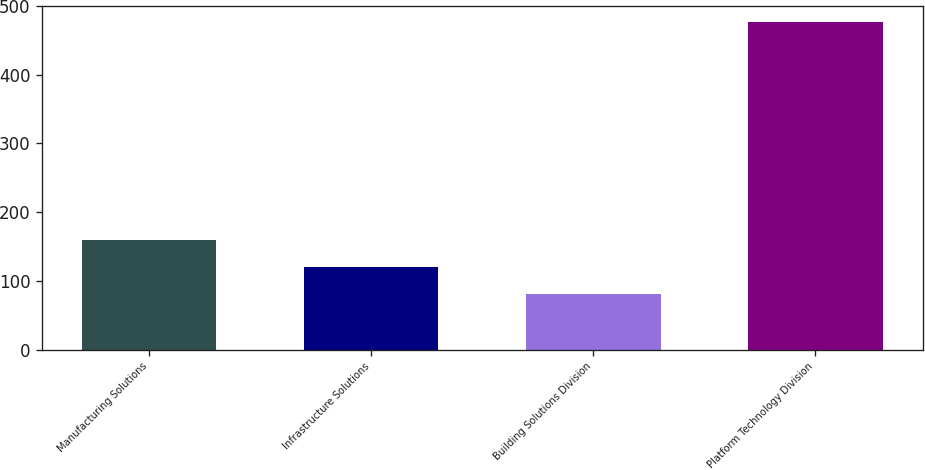Convert chart. <chart><loc_0><loc_0><loc_500><loc_500><bar_chart><fcel>Manufacturing Solutions<fcel>Infrastructure Solutions<fcel>Building Solutions Division<fcel>Platform Technology Division<nl><fcel>159.58<fcel>119.94<fcel>80.3<fcel>476.7<nl></chart> 